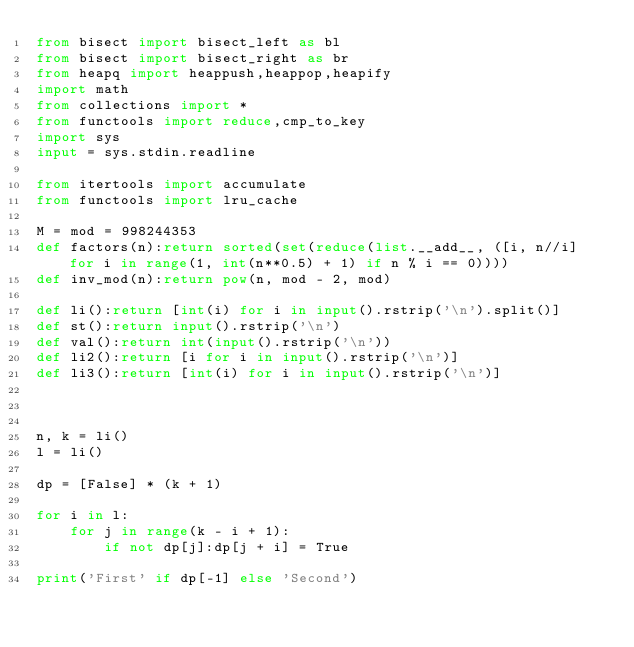Convert code to text. <code><loc_0><loc_0><loc_500><loc_500><_Python_>from bisect import bisect_left as bl
from bisect import bisect_right as br
from heapq import heappush,heappop,heapify
import math
from collections import *
from functools import reduce,cmp_to_key
import sys
input = sys.stdin.readline

from itertools import accumulate
from functools import lru_cache

M = mod = 998244353
def factors(n):return sorted(set(reduce(list.__add__, ([i, n//i] for i in range(1, int(n**0.5) + 1) if n % i == 0))))
def inv_mod(n):return pow(n, mod - 2, mod)
 
def li():return [int(i) for i in input().rstrip('\n').split()]
def st():return input().rstrip('\n')
def val():return int(input().rstrip('\n'))
def li2():return [i for i in input().rstrip('\n')]
def li3():return [int(i) for i in input().rstrip('\n')]



n, k = li()
l = li()

dp = [False] * (k + 1)

for i in l:
    for j in range(k - i + 1):
        if not dp[j]:dp[j + i] = True

print('First' if dp[-1] else 'Second')</code> 